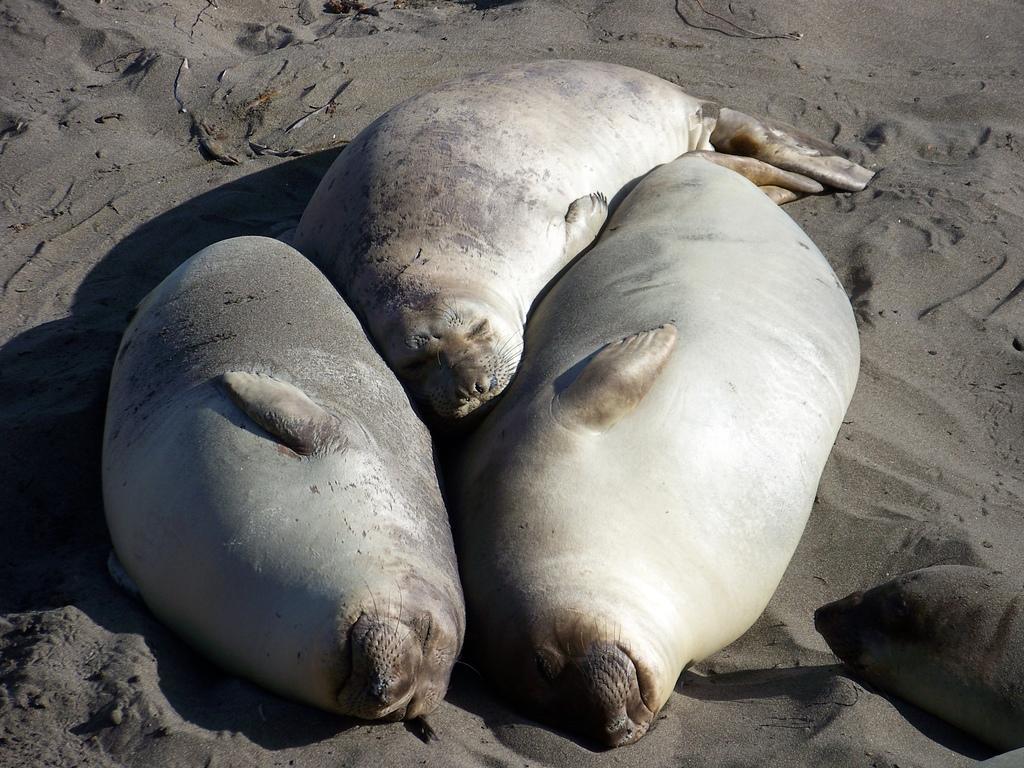How would you summarize this image in a sentence or two? In the picture I can see harbor seal animals sleeping on the sand. 